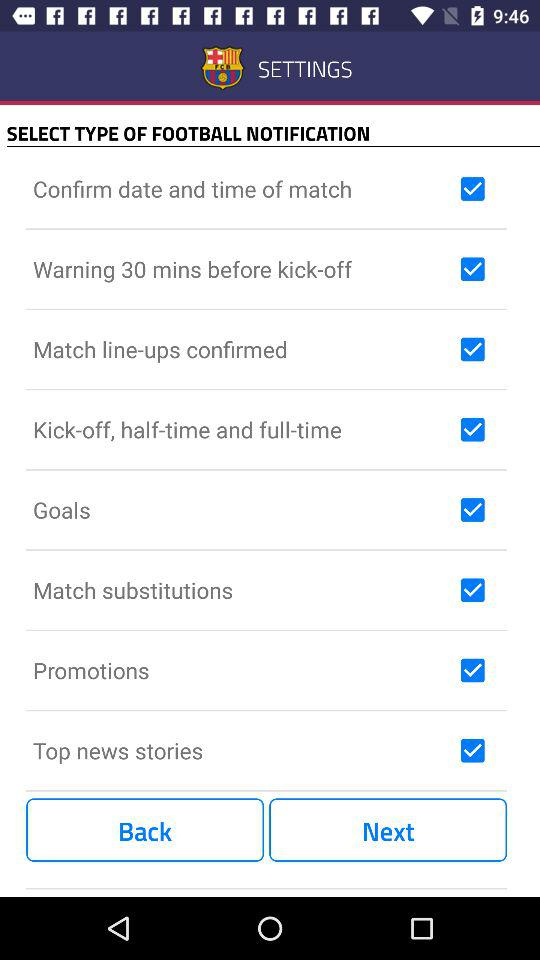What time will the kick-off warning be notified? The warning will be notified 30 minutes before kick-off. 